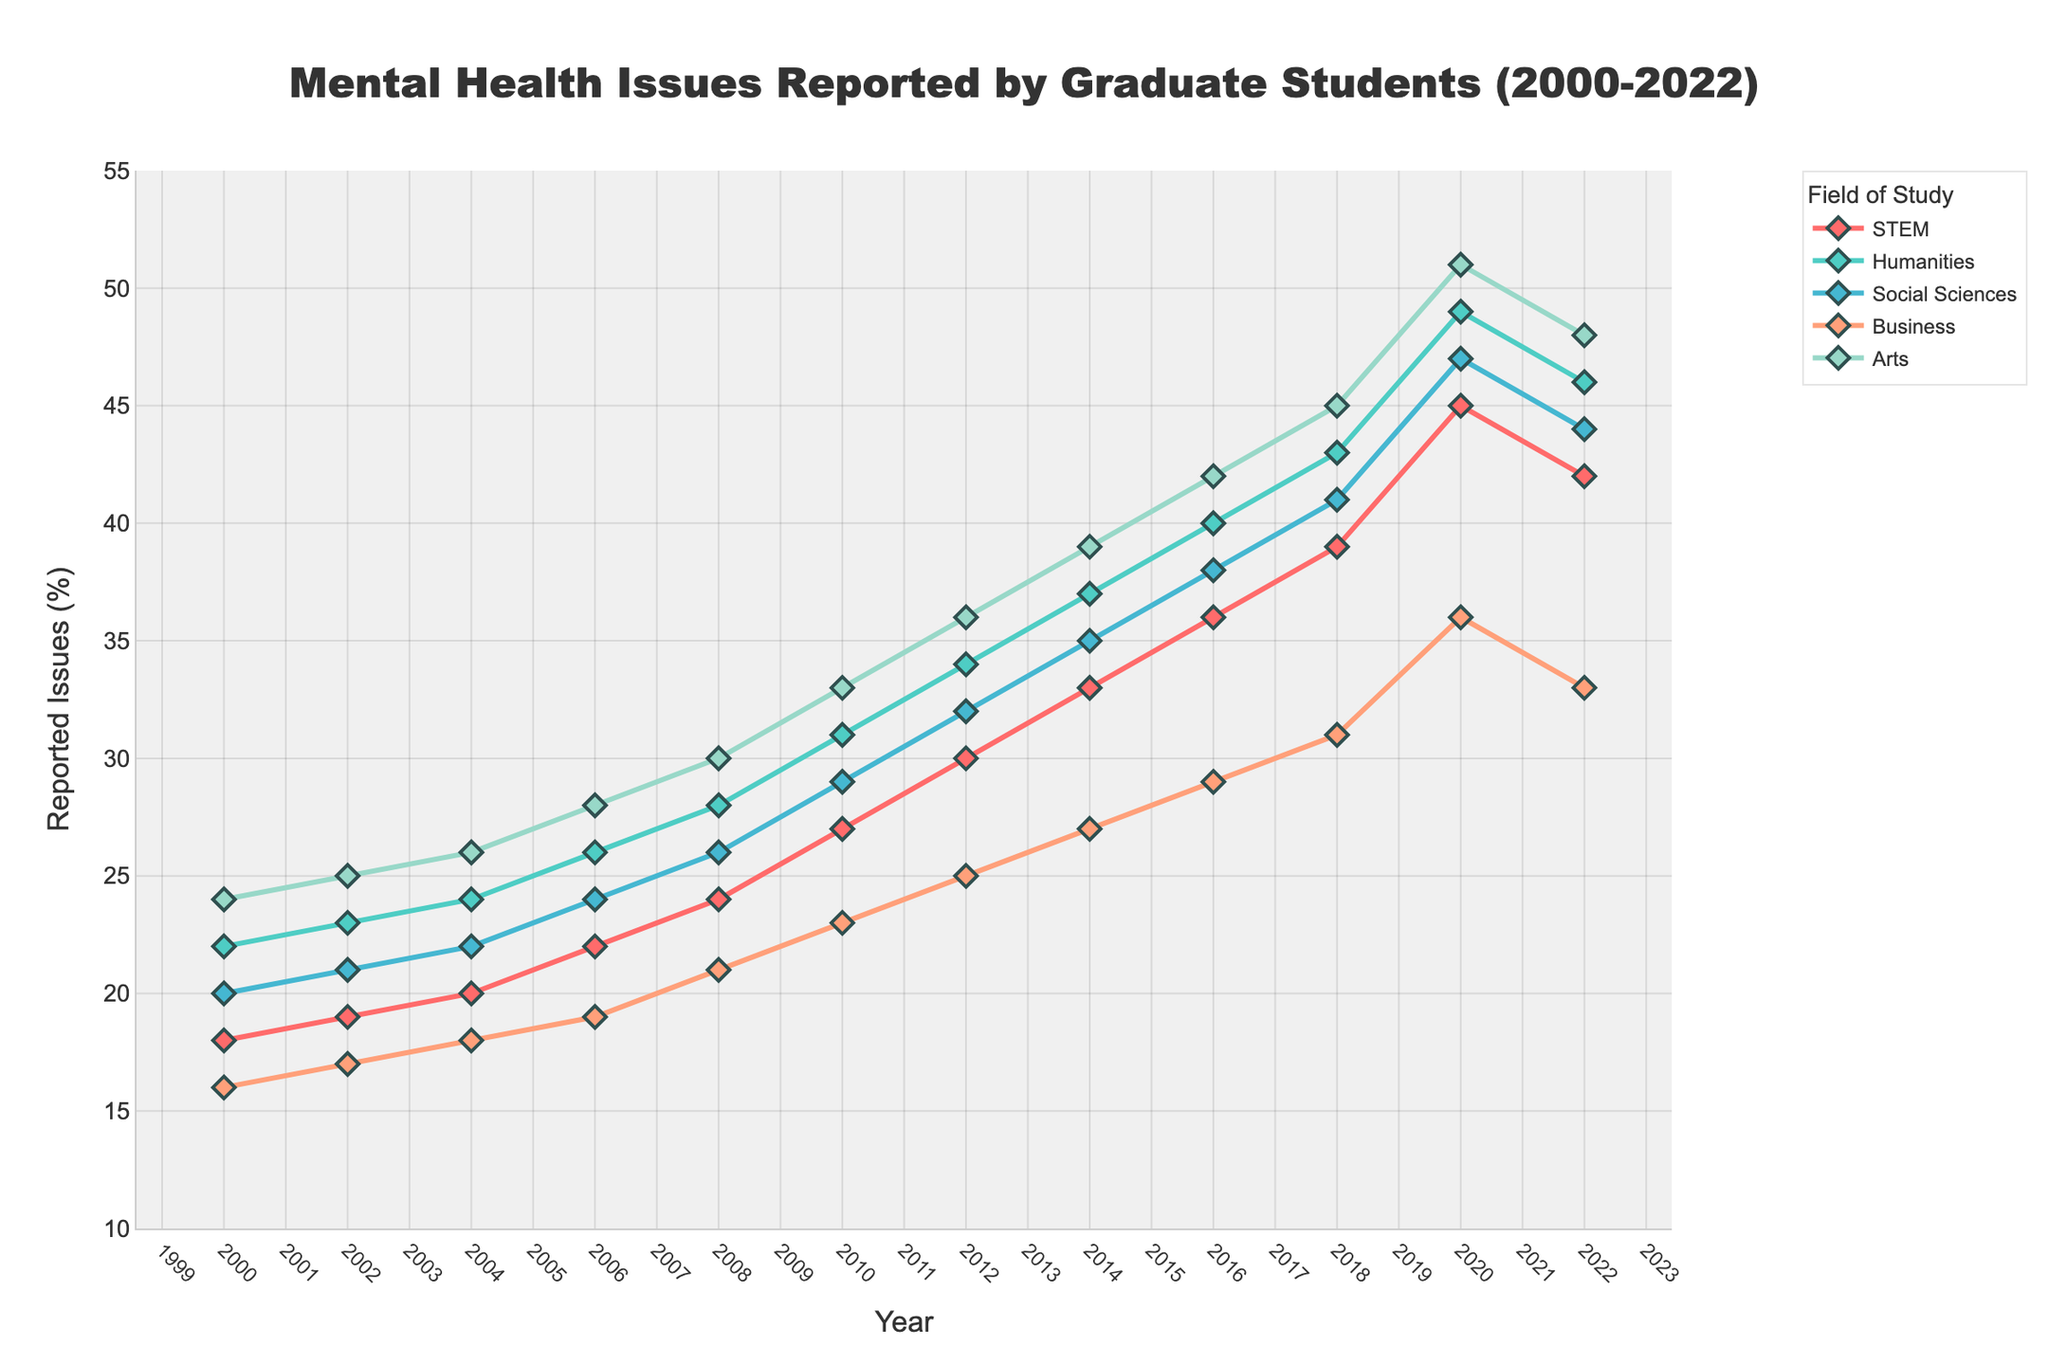What year did STEM and Social Sciences report the same amount of mental health issues? By observing the line chart, locate the points where the lines for STEM and Social Sciences intersect. Check the corresponding year on the x-axis.
Answer: 2022 Between 2010 and 2020, which field showed the greatest increase in reported mental health issues? Identify each field's data points for 2010 and 2020. Calculate the difference for each field: Humanities (49-31=18), STEM (45-27=18), Social Sciences (47-29=18), Business (36-23=13), Arts (51-33=18). Humanities, STEM, Social Sciences, and Arts all show the greatest increase, which is 18%.
Answer: Humanities, STEM, Social Sciences, and Arts In 2018, how many fields reported mental health issues above 40%? Check the y-values for each field in 2018 and count how many fields are above 40%. Humanities (43), STEM (39), Social Sciences (41), Business (31), Arts (45). Humanities, Social Sciences, and Arts are above 40%.
Answer: 3 Which field had the biggest decline in reported mental health issues from 2020 to 2022? Calculate the difference in reported mental health issues for each field from 2020 to 2022: STEM (45-42=3), Humanities (49-46=3), Social Sciences (47-44=3), Business (36-33=3), Arts (51-48=3). All fields had the same decline.
Answer: All fields (3% decrease) What is the average percentage of reported mental health issues in Business across the entire time period? add all percentages from the Business column and divide by the number of years. (16+17+18+19+21+23+25+27+29+31+36+33)=295, 295 divided by 12 (number of data points) is approximately 24.58
Answer: 24.58 In which year did Arts reach its peak in reported mental health issues? Observe the highest point of the orange line representing Arts and note the corresponding year on the x-axis.
Answer: 2020 Describe the trend of mental health issues reported by Humanities from 2000 to 2022. Observe the overall direction and changes of the Humanities line (cyan) from the start (22 in 2000) to the end (46 in 2022). Note consistent increases followed by slight drops.
Answer: Increasing with fluctuation 